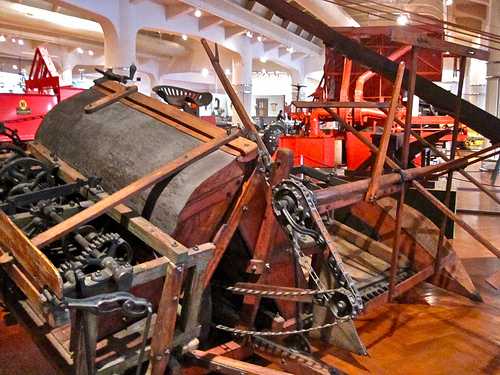<image>
Can you confirm if the chain is on the pully? Yes. Looking at the image, I can see the chain is positioned on top of the pully, with the pully providing support. 